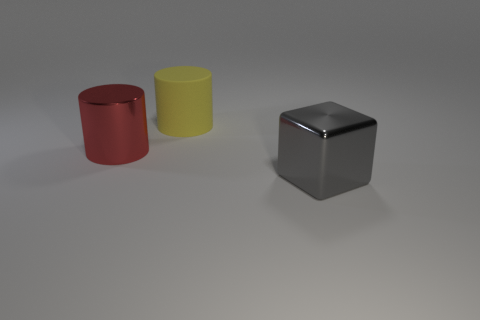Add 1 big blue metallic things. How many objects exist? 4 Subtract all blocks. How many objects are left? 2 Subtract 0 brown cylinders. How many objects are left? 3 Subtract all small cyan rubber things. Subtract all big metal things. How many objects are left? 1 Add 2 big cylinders. How many big cylinders are left? 4 Add 3 tiny cyan rubber things. How many tiny cyan rubber things exist? 3 